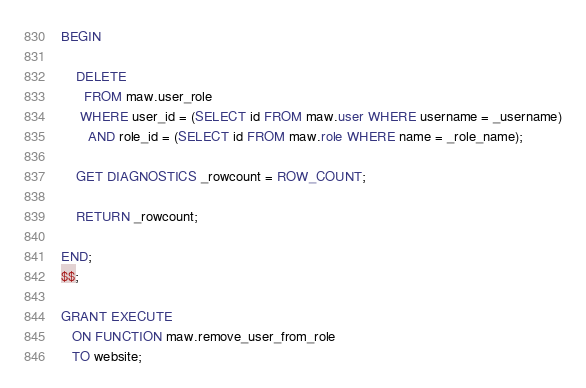Convert code to text. <code><loc_0><loc_0><loc_500><loc_500><_SQL_>BEGIN

    DELETE
      FROM maw.user_role
     WHERE user_id = (SELECT id FROM maw.user WHERE username = _username)
       AND role_id = (SELECT id FROM maw.role WHERE name = _role_name);

    GET DIAGNOSTICS _rowcount = ROW_COUNT;

    RETURN _rowcount;

END;
$$;

GRANT EXECUTE
   ON FUNCTION maw.remove_user_from_role
   TO website;
</code> 